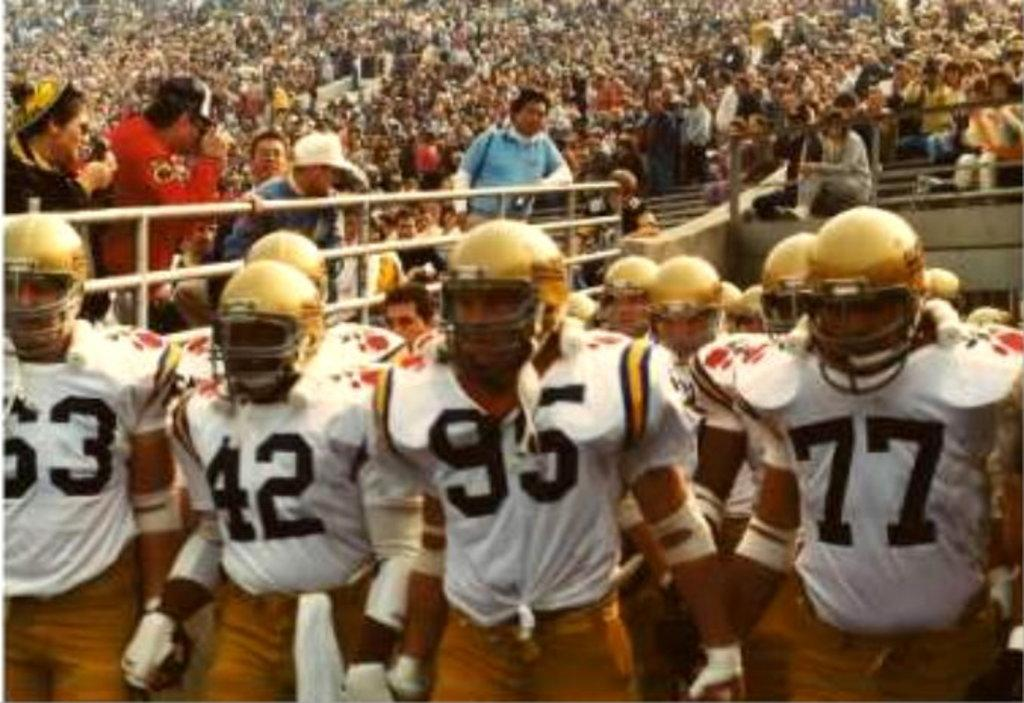What is the main subject of the image? The main subject of the image is a team. What are the team members doing with their hands? The team members are holding their hands. What color are the t-shirts worn by the team members? The team members are wearing white t-shirts. What type of headgear are the team members wearing? The team members are wearing yellow helmets. Can you describe the people behind the team? There are many people behind the team, but their specific actions or characteristics are not mentioned in the provided facts. What type of cloth is draped over the team members' eyes in the image? There is no cloth or any indication of blindfolds in the image; the team members are wearing yellow helmets. 